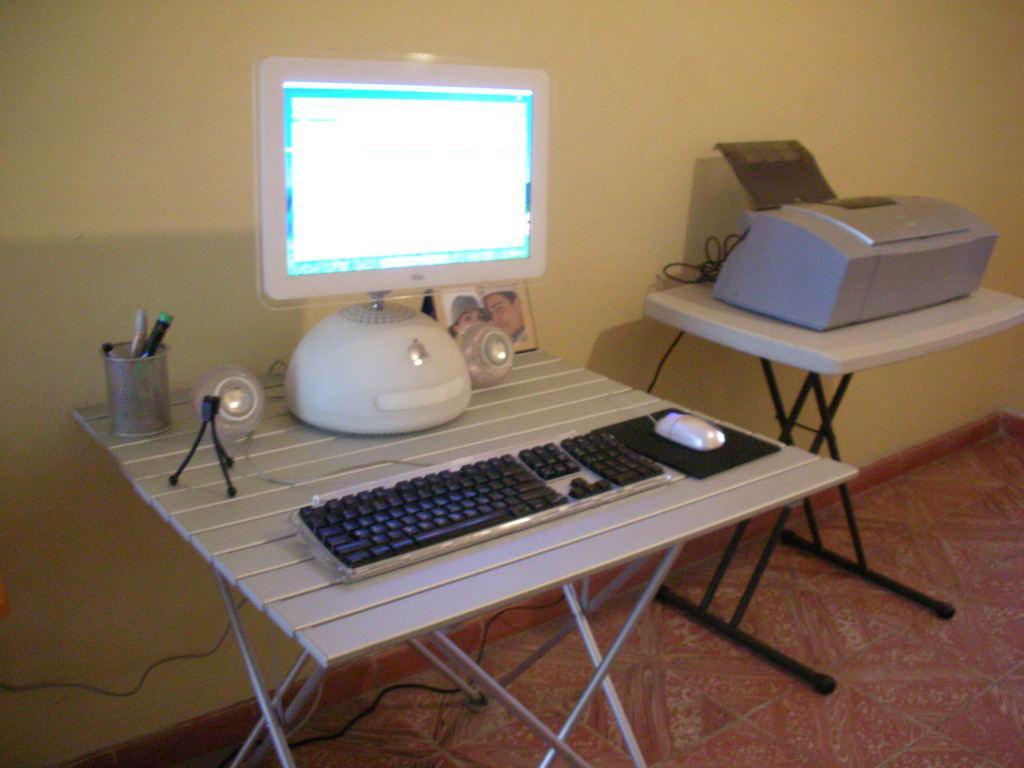Please provide a concise description of this image. In the center of the image we can see monitor, keyboard, mouse, mouse pad, photo frame, pins placed on the table. On the right side of the image we can see printer placed on the table. In the background there is wall. 